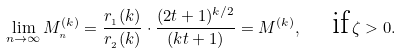Convert formula to latex. <formula><loc_0><loc_0><loc_500><loc_500>\lim _ { n \rightarrow \infty } M _ { _ { n } } ^ { ( k ) } = \frac { r _ { _ { 1 } } ( k ) } { r _ { _ { 2 } } ( k ) } \cdot \frac { ( 2 t + 1 ) ^ { k / 2 } } { ( k t + 1 ) } = M ^ { ( k ) } , \quad \text {if} \, \zeta > 0 .</formula> 